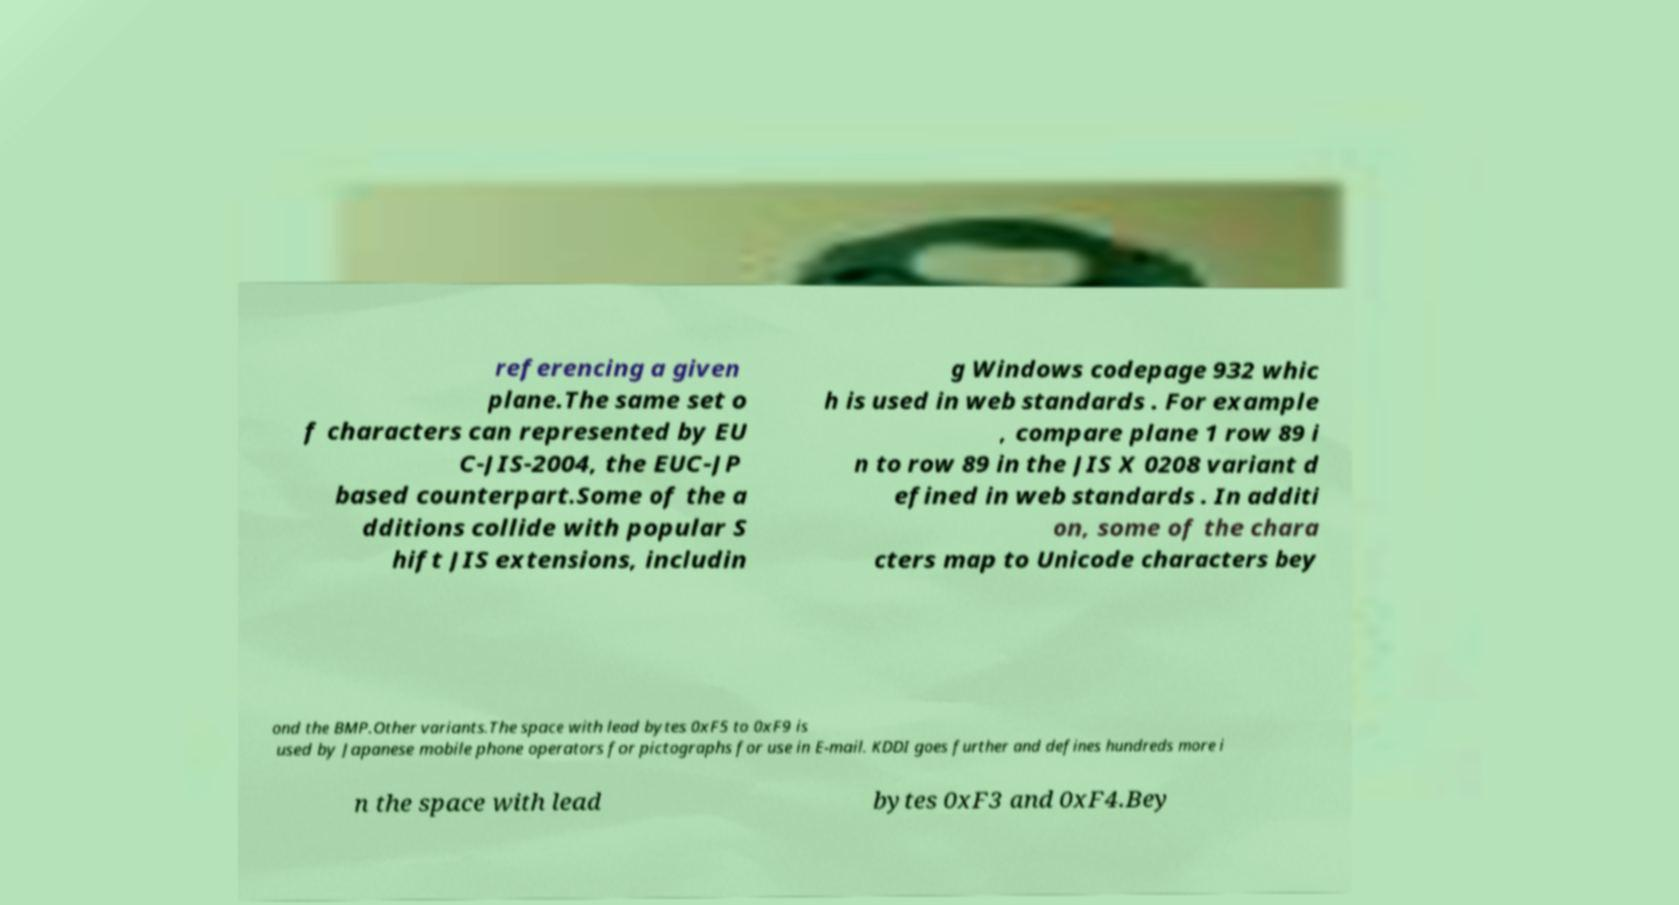Please identify and transcribe the text found in this image. referencing a given plane.The same set o f characters can represented by EU C-JIS-2004, the EUC-JP based counterpart.Some of the a dditions collide with popular S hift JIS extensions, includin g Windows codepage 932 whic h is used in web standards . For example , compare plane 1 row 89 i n to row 89 in the JIS X 0208 variant d efined in web standards . In additi on, some of the chara cters map to Unicode characters bey ond the BMP.Other variants.The space with lead bytes 0xF5 to 0xF9 is used by Japanese mobile phone operators for pictographs for use in E-mail. KDDI goes further and defines hundreds more i n the space with lead bytes 0xF3 and 0xF4.Bey 